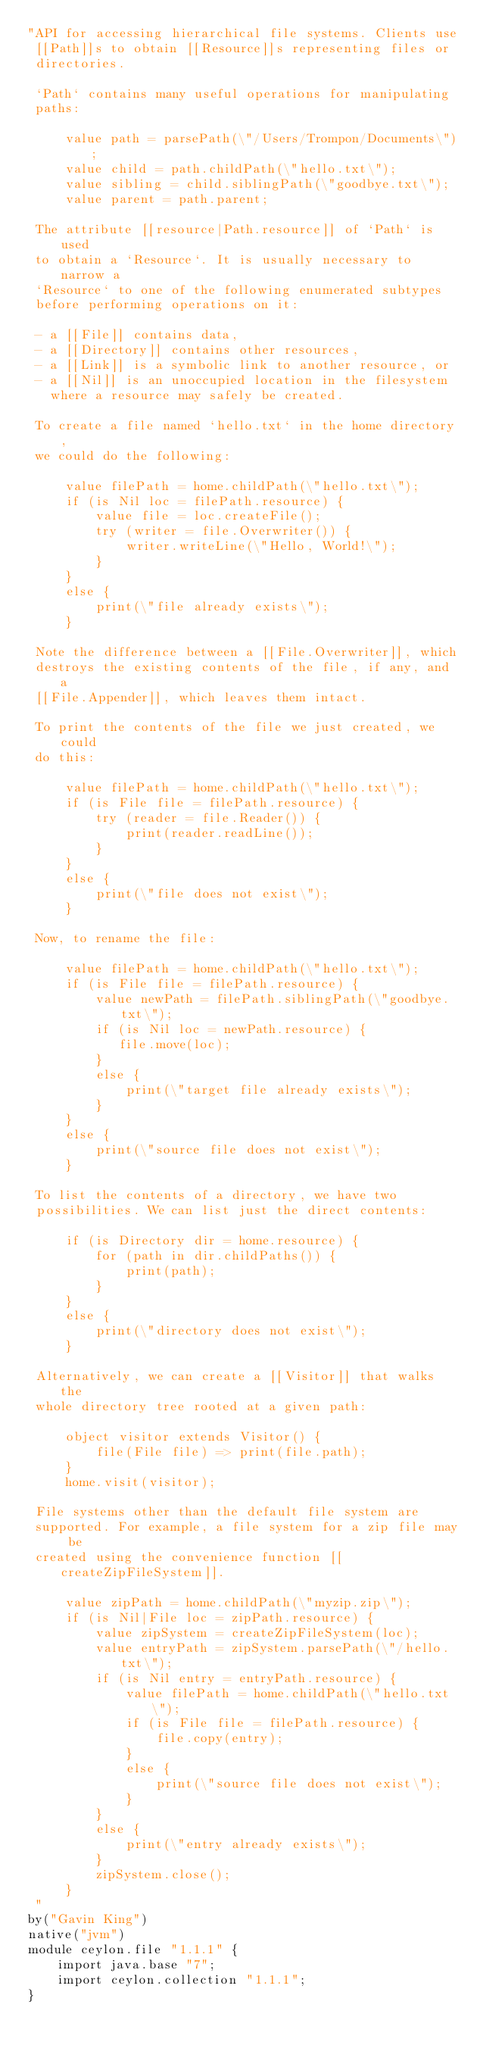Convert code to text. <code><loc_0><loc_0><loc_500><loc_500><_Ceylon_>"API for accessing hierarchical file systems. Clients use 
 [[Path]]s to obtain [[Resource]]s representing files or 
 directories.
 
 `Path` contains many useful operations for manipulating 
 paths:
 
     value path = parsePath(\"/Users/Trompon/Documents\");
     value child = path.childPath(\"hello.txt\");
     value sibling = child.siblingPath(\"goodbye.txt\");
     value parent = path.parent;
 
 The attribute [[resource|Path.resource]] of `Path` is used 
 to obtain a `Resource`. It is usually necessary to narrow a 
 `Resource` to one of the following enumerated subtypes 
 before performing operations on it:
 
 - a [[File]] contains data,
 - a [[Directory]] contains other resources, 
 - a [[Link]] is a symbolic link to another resource, or 
 - a [[Nil]] is an unoccupied location in the filesystem 
   where a resource may safely be created.
 
 To create a file named `hello.txt` in the home directory, 
 we could do the following:
 
     value filePath = home.childPath(\"hello.txt\");
     if (is Nil loc = filePath.resource) {
         value file = loc.createFile();
         try (writer = file.Overwriter()) {
             writer.writeLine(\"Hello, World!\");
         }
     }
     else {
         print(\"file already exists\");
     }
 
 Note the difference between a [[File.Overwriter]], which 
 destroys the existing contents of the file, if any, and a 
 [[File.Appender]], which leaves them intact.
 
 To print the contents of the file we just created, we could 
 do this:
 
     value filePath = home.childPath(\"hello.txt\");
     if (is File file = filePath.resource) {
         try (reader = file.Reader()) {
             print(reader.readLine());
         }
     }
     else {
         print(\"file does not exist\");
     }
 
 Now, to rename the file:
 
     value filePath = home.childPath(\"hello.txt\");
     if (is File file = filePath.resource) {
         value newPath = filePath.siblingPath(\"goodbye.txt\");
         if (is Nil loc = newPath.resource) {
            file.move(loc);
         }
         else {
             print(\"target file already exists\");
         }
     }
     else {
         print(\"source file does not exist\");
     }
 
 To list the contents of a directory, we have two 
 possibilities. We can list just the direct contents:
 
     if (is Directory dir = home.resource) {
         for (path in dir.childPaths()) {
             print(path);
         }
     }
     else {
         print(\"directory does not exist\");
     }
 
 Alternatively, we can create a [[Visitor]] that walks the
 whole directory tree rooted at a given path:
 
     object visitor extends Visitor() {
         file(File file) => print(file.path);
     }
     home.visit(visitor);
 
 File systems other than the default file system are 
 supported. For example, a file system for a zip file may be 
 created using the convenience function [[createZipFileSystem]].
 
     value zipPath = home.childPath(\"myzip.zip\");
     if (is Nil|File loc = zipPath.resource) {
         value zipSystem = createZipFileSystem(loc);
         value entryPath = zipSystem.parsePath(\"/hello.txt\");
         if (is Nil entry = entryPath.resource) {
             value filePath = home.childPath(\"hello.txt\");
             if (is File file = filePath.resource) {
                 file.copy(entry);
             }
             else {
                 print(\"source file does not exist\");
             }
         }
         else {
             print(\"entry already exists\");
         }
         zipSystem.close();
     }
 "
by("Gavin King")
native("jvm")
module ceylon.file "1.1.1" {
    import java.base "7";
    import ceylon.collection "1.1.1";
}
</code> 